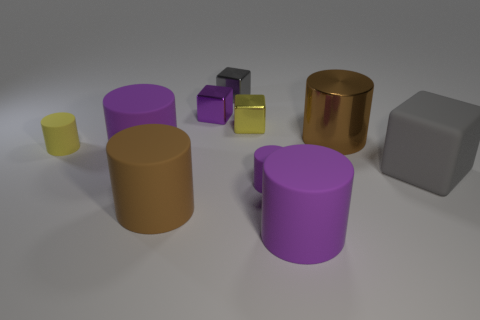Are there any other things that have the same color as the large shiny thing?
Keep it short and to the point. Yes. There is a big matte cylinder to the right of the brown thing in front of the large gray rubber cube; what number of brown cylinders are to the left of it?
Your response must be concise. 1. What number of red things are either large rubber cubes or small objects?
Your response must be concise. 0. There is a yellow cylinder; does it have the same size as the brown thing in front of the big gray rubber object?
Make the answer very short. No. There is a tiny purple thing that is the same shape as the brown metallic thing; what material is it?
Provide a short and direct response. Rubber. What number of other things are the same size as the gray metal object?
Your answer should be compact. 4. The brown thing on the left side of the gray block that is on the left side of the big purple matte object to the right of the tiny purple shiny object is what shape?
Provide a short and direct response. Cylinder. The shiny thing that is right of the tiny gray shiny block and on the left side of the metallic cylinder has what shape?
Offer a very short reply. Cube. What number of things are big red balls or cylinders that are behind the large gray matte cube?
Provide a short and direct response. 3. Is the yellow cube made of the same material as the yellow cylinder?
Keep it short and to the point. No. 